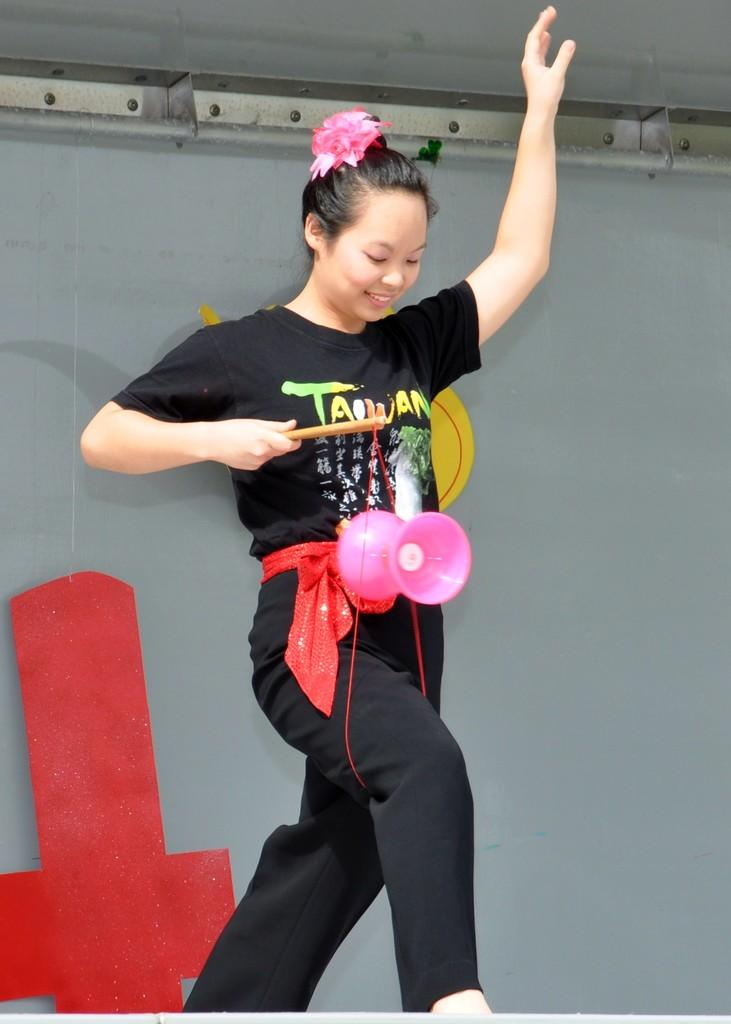Who is the main subject in the image? There is a girl in the image. What is the girl wearing? The girl is wearing a black t-shirt and track. What accessory is the girl wearing around her neck? The girl is wearing a pink color speaker around her neck. What is the girl doing in the image? The girl is walking on a rope. What is the color of the background in the image? The background of the image is grey. What type of winter treatment is the girl receiving in the image? There is no indication of any winter treatment in the image; the girl is walking on a rope with a speaker around her neck. How high is the girl jumping in the image? The girl is not jumping in the image; she is walking on a rope. 